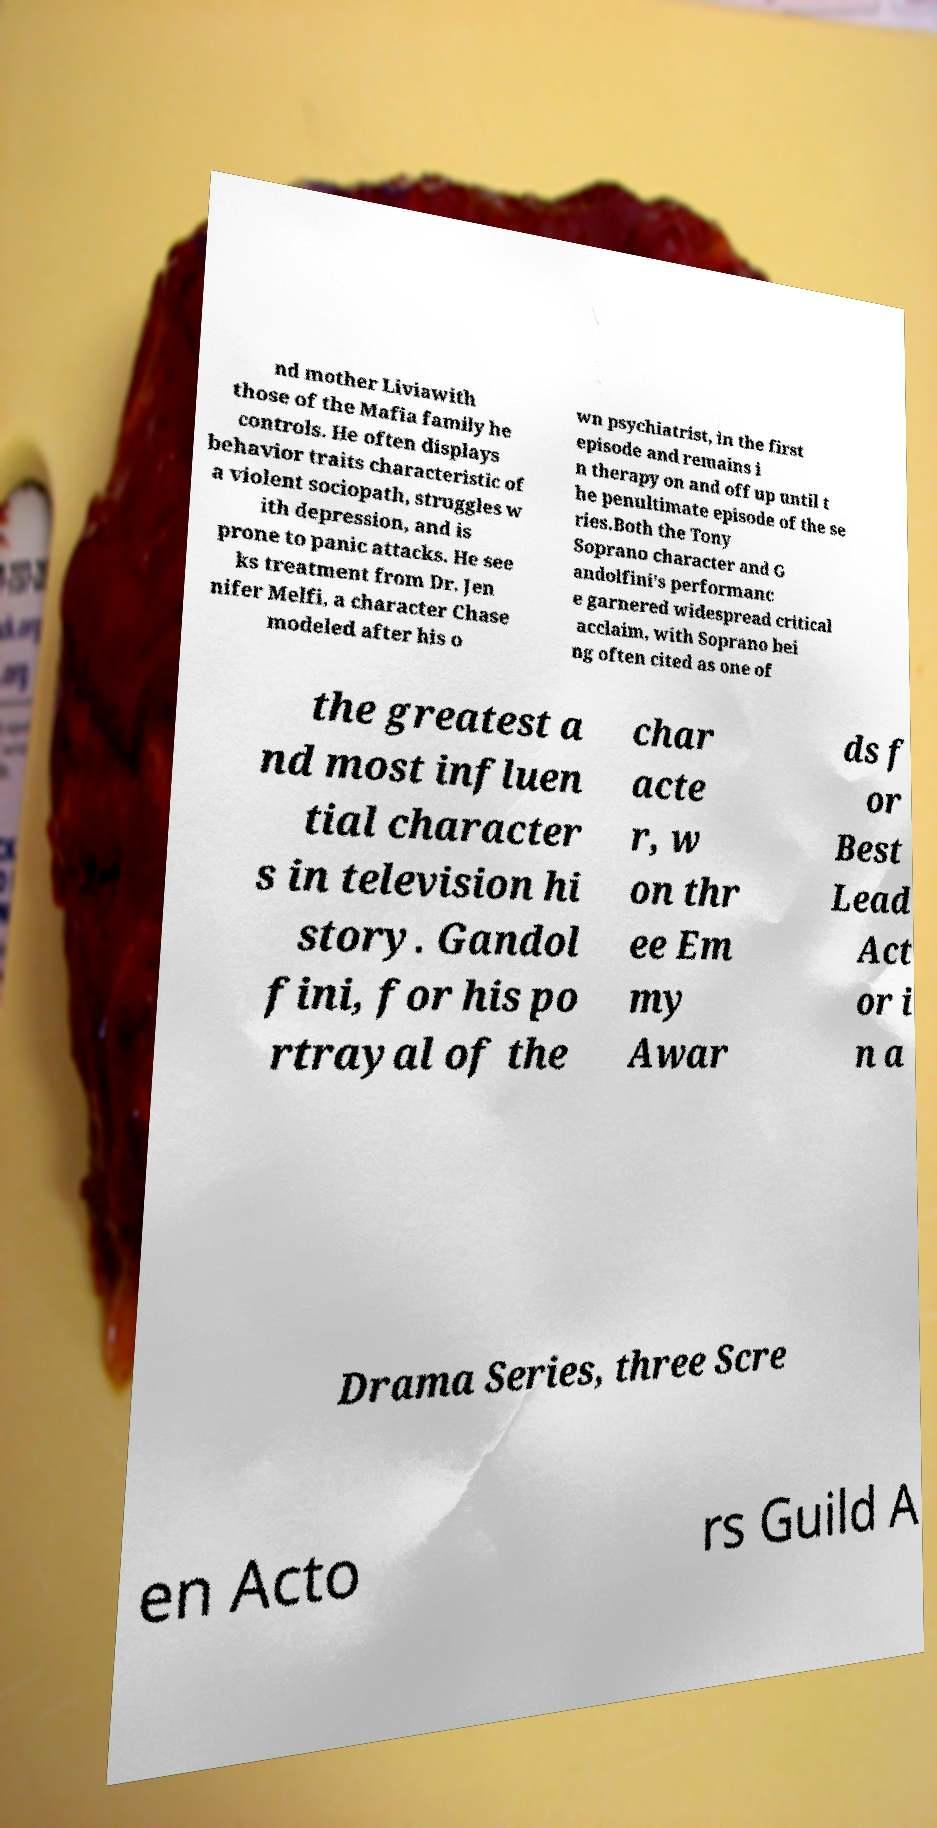I need the written content from this picture converted into text. Can you do that? nd mother Liviawith those of the Mafia family he controls. He often displays behavior traits characteristic of a violent sociopath, struggles w ith depression, and is prone to panic attacks. He see ks treatment from Dr. Jen nifer Melfi, a character Chase modeled after his o wn psychiatrist, in the first episode and remains i n therapy on and off up until t he penultimate episode of the se ries.Both the Tony Soprano character and G andolfini's performanc e garnered widespread critical acclaim, with Soprano bei ng often cited as one of the greatest a nd most influen tial character s in television hi story. Gandol fini, for his po rtrayal of the char acte r, w on thr ee Em my Awar ds f or Best Lead Act or i n a Drama Series, three Scre en Acto rs Guild A 